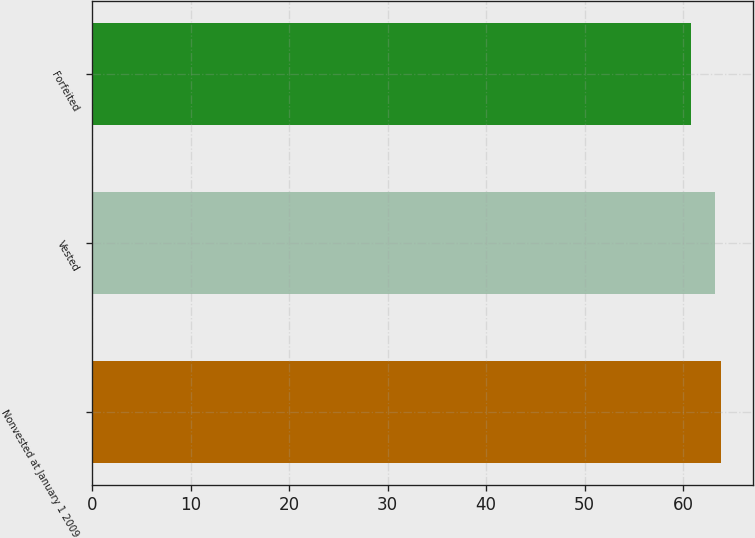Convert chart. <chart><loc_0><loc_0><loc_500><loc_500><bar_chart><fcel>Nonvested at January 1 2009<fcel>Vested<fcel>Forfeited<nl><fcel>63.9<fcel>63.23<fcel>60.8<nl></chart> 